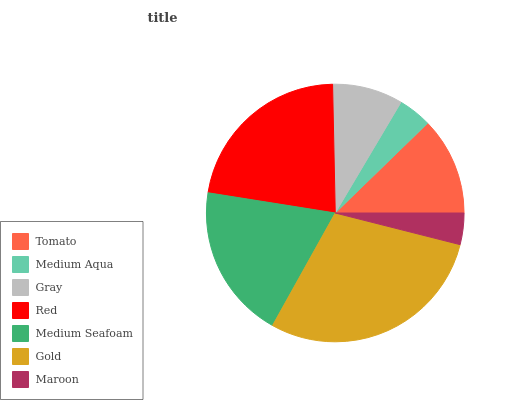Is Maroon the minimum?
Answer yes or no. Yes. Is Gold the maximum?
Answer yes or no. Yes. Is Medium Aqua the minimum?
Answer yes or no. No. Is Medium Aqua the maximum?
Answer yes or no. No. Is Tomato greater than Medium Aqua?
Answer yes or no. Yes. Is Medium Aqua less than Tomato?
Answer yes or no. Yes. Is Medium Aqua greater than Tomato?
Answer yes or no. No. Is Tomato less than Medium Aqua?
Answer yes or no. No. Is Tomato the high median?
Answer yes or no. Yes. Is Tomato the low median?
Answer yes or no. Yes. Is Gray the high median?
Answer yes or no. No. Is Medium Aqua the low median?
Answer yes or no. No. 